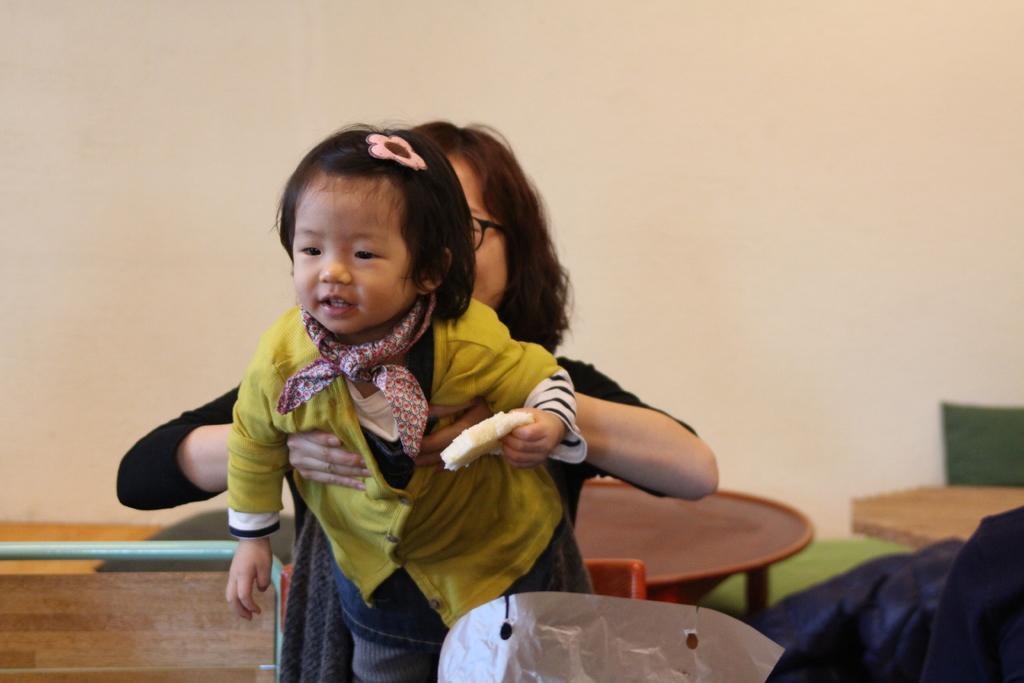Please provide a concise description of this image. In this picture we can see a woman and a kid, this kid is holding something, there is a table in the middle, in the background we can see a wall, it looks like a cloth at the right bottom. 